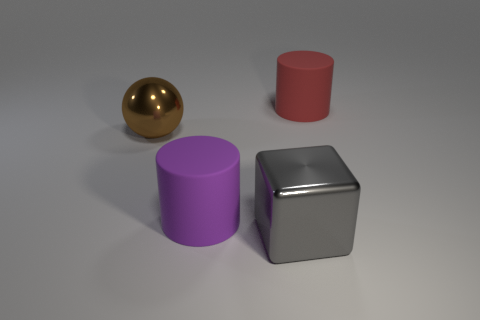How many big red cylinders are behind the large thing that is on the right side of the big metal block?
Offer a very short reply. 0. What number of big matte things are both in front of the red matte object and on the right side of the big gray shiny block?
Provide a succinct answer. 0. How many objects are either tiny green things or gray metallic objects on the right side of the large purple cylinder?
Give a very brief answer. 1. What shape is the shiny object to the left of the big matte object that is in front of the red cylinder?
Provide a succinct answer. Sphere. How many gray things are large metal cubes or large balls?
Your answer should be compact. 1. There is a large metal object that is to the right of the large ball that is behind the purple thing; is there a big shiny object that is left of it?
Offer a very short reply. Yes. How many small objects are rubber cylinders or purple cylinders?
Keep it short and to the point. 0. Does the rubber object on the left side of the large red matte cylinder have the same shape as the large red thing?
Your response must be concise. Yes. Is the number of purple cylinders less than the number of large blue shiny balls?
Provide a succinct answer. No. Are there any other things that are the same color as the large sphere?
Your answer should be very brief. No. 